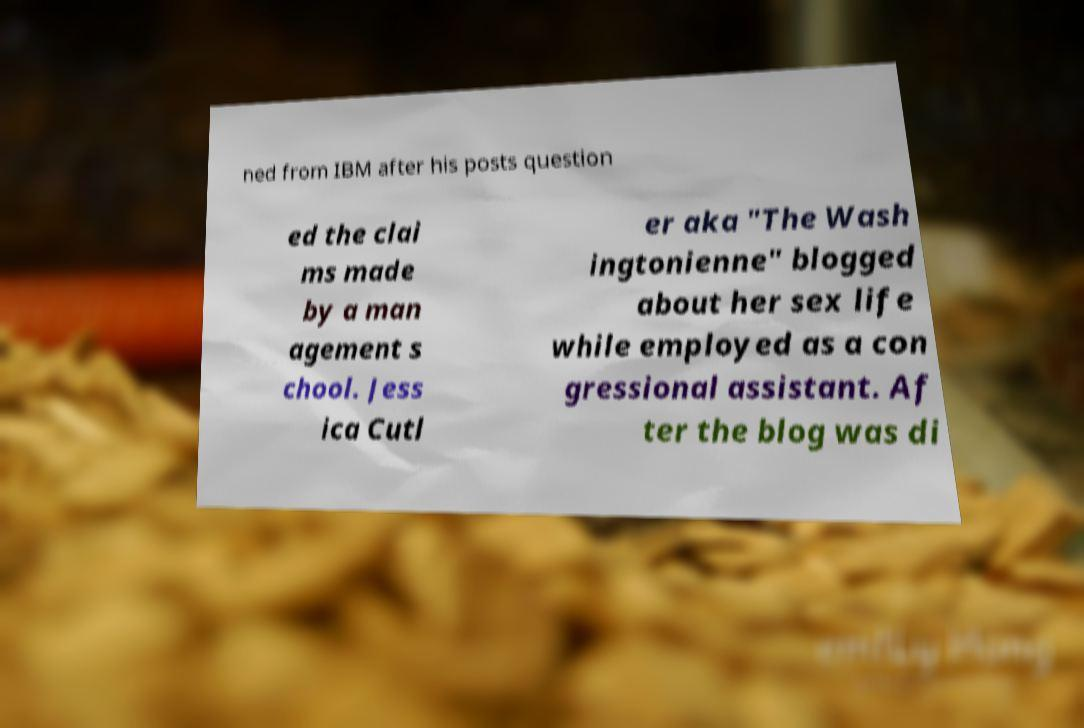What messages or text are displayed in this image? I need them in a readable, typed format. ned from IBM after his posts question ed the clai ms made by a man agement s chool. Jess ica Cutl er aka "The Wash ingtonienne" blogged about her sex life while employed as a con gressional assistant. Af ter the blog was di 